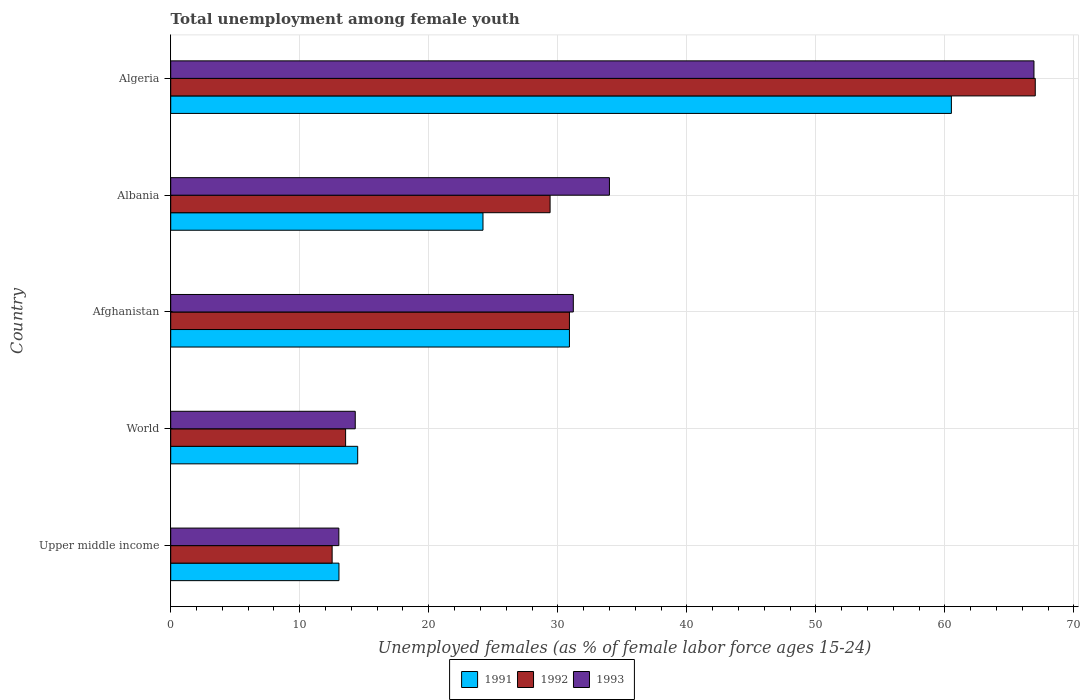How many different coloured bars are there?
Offer a terse response. 3. How many groups of bars are there?
Offer a terse response. 5. What is the label of the 3rd group of bars from the top?
Your response must be concise. Afghanistan. In how many cases, is the number of bars for a given country not equal to the number of legend labels?
Offer a very short reply. 0. What is the percentage of unemployed females in in 1991 in Afghanistan?
Keep it short and to the point. 30.9. Across all countries, what is the maximum percentage of unemployed females in in 1993?
Make the answer very short. 66.9. Across all countries, what is the minimum percentage of unemployed females in in 1993?
Your response must be concise. 13.03. In which country was the percentage of unemployed females in in 1993 maximum?
Give a very brief answer. Algeria. In which country was the percentage of unemployed females in in 1992 minimum?
Offer a very short reply. Upper middle income. What is the total percentage of unemployed females in in 1993 in the graph?
Keep it short and to the point. 159.43. What is the difference between the percentage of unemployed females in in 1992 in Albania and that in World?
Offer a very short reply. 15.85. What is the difference between the percentage of unemployed females in in 1992 in Algeria and the percentage of unemployed females in in 1993 in World?
Provide a succinct answer. 52.7. What is the average percentage of unemployed females in in 1993 per country?
Your answer should be very brief. 31.89. What is the difference between the percentage of unemployed females in in 1992 and percentage of unemployed females in in 1991 in Afghanistan?
Provide a succinct answer. 0. In how many countries, is the percentage of unemployed females in in 1993 greater than 52 %?
Ensure brevity in your answer.  1. What is the ratio of the percentage of unemployed females in in 1992 in Afghanistan to that in Upper middle income?
Provide a succinct answer. 2.47. Is the percentage of unemployed females in in 1992 in Upper middle income less than that in World?
Ensure brevity in your answer.  Yes. Is the difference between the percentage of unemployed females in in 1992 in Algeria and World greater than the difference between the percentage of unemployed females in in 1991 in Algeria and World?
Your answer should be very brief. Yes. What is the difference between the highest and the second highest percentage of unemployed females in in 1991?
Provide a short and direct response. 29.6. What is the difference between the highest and the lowest percentage of unemployed females in in 1992?
Provide a succinct answer. 54.49. What does the 2nd bar from the bottom in World represents?
Give a very brief answer. 1992. Is it the case that in every country, the sum of the percentage of unemployed females in in 1992 and percentage of unemployed females in in 1993 is greater than the percentage of unemployed females in in 1991?
Offer a terse response. Yes. How many countries are there in the graph?
Keep it short and to the point. 5. Are the values on the major ticks of X-axis written in scientific E-notation?
Ensure brevity in your answer.  No. Does the graph contain any zero values?
Your answer should be compact. No. Where does the legend appear in the graph?
Ensure brevity in your answer.  Bottom center. How many legend labels are there?
Ensure brevity in your answer.  3. What is the title of the graph?
Give a very brief answer. Total unemployment among female youth. Does "1983" appear as one of the legend labels in the graph?
Keep it short and to the point. No. What is the label or title of the X-axis?
Provide a short and direct response. Unemployed females (as % of female labor force ages 15-24). What is the label or title of the Y-axis?
Give a very brief answer. Country. What is the Unemployed females (as % of female labor force ages 15-24) in 1991 in Upper middle income?
Ensure brevity in your answer.  13.04. What is the Unemployed females (as % of female labor force ages 15-24) in 1992 in Upper middle income?
Offer a very short reply. 12.51. What is the Unemployed females (as % of female labor force ages 15-24) of 1993 in Upper middle income?
Keep it short and to the point. 13.03. What is the Unemployed females (as % of female labor force ages 15-24) in 1991 in World?
Offer a very short reply. 14.49. What is the Unemployed females (as % of female labor force ages 15-24) in 1992 in World?
Make the answer very short. 13.55. What is the Unemployed females (as % of female labor force ages 15-24) in 1993 in World?
Provide a short and direct response. 14.3. What is the Unemployed females (as % of female labor force ages 15-24) of 1991 in Afghanistan?
Provide a short and direct response. 30.9. What is the Unemployed females (as % of female labor force ages 15-24) of 1992 in Afghanistan?
Offer a very short reply. 30.9. What is the Unemployed females (as % of female labor force ages 15-24) in 1993 in Afghanistan?
Ensure brevity in your answer.  31.2. What is the Unemployed females (as % of female labor force ages 15-24) of 1991 in Albania?
Keep it short and to the point. 24.2. What is the Unemployed females (as % of female labor force ages 15-24) in 1992 in Albania?
Offer a terse response. 29.4. What is the Unemployed females (as % of female labor force ages 15-24) of 1991 in Algeria?
Make the answer very short. 60.5. What is the Unemployed females (as % of female labor force ages 15-24) of 1992 in Algeria?
Provide a short and direct response. 67. What is the Unemployed females (as % of female labor force ages 15-24) of 1993 in Algeria?
Give a very brief answer. 66.9. Across all countries, what is the maximum Unemployed females (as % of female labor force ages 15-24) in 1991?
Offer a terse response. 60.5. Across all countries, what is the maximum Unemployed females (as % of female labor force ages 15-24) of 1992?
Your response must be concise. 67. Across all countries, what is the maximum Unemployed females (as % of female labor force ages 15-24) in 1993?
Provide a short and direct response. 66.9. Across all countries, what is the minimum Unemployed females (as % of female labor force ages 15-24) in 1991?
Your response must be concise. 13.04. Across all countries, what is the minimum Unemployed females (as % of female labor force ages 15-24) of 1992?
Offer a terse response. 12.51. Across all countries, what is the minimum Unemployed females (as % of female labor force ages 15-24) of 1993?
Offer a very short reply. 13.03. What is the total Unemployed females (as % of female labor force ages 15-24) in 1991 in the graph?
Your response must be concise. 143.13. What is the total Unemployed females (as % of female labor force ages 15-24) in 1992 in the graph?
Give a very brief answer. 153.36. What is the total Unemployed females (as % of female labor force ages 15-24) in 1993 in the graph?
Make the answer very short. 159.43. What is the difference between the Unemployed females (as % of female labor force ages 15-24) in 1991 in Upper middle income and that in World?
Offer a terse response. -1.45. What is the difference between the Unemployed females (as % of female labor force ages 15-24) of 1992 in Upper middle income and that in World?
Make the answer very short. -1.04. What is the difference between the Unemployed females (as % of female labor force ages 15-24) of 1993 in Upper middle income and that in World?
Your answer should be compact. -1.27. What is the difference between the Unemployed females (as % of female labor force ages 15-24) in 1991 in Upper middle income and that in Afghanistan?
Give a very brief answer. -17.86. What is the difference between the Unemployed females (as % of female labor force ages 15-24) in 1992 in Upper middle income and that in Afghanistan?
Your answer should be compact. -18.39. What is the difference between the Unemployed females (as % of female labor force ages 15-24) of 1993 in Upper middle income and that in Afghanistan?
Your response must be concise. -18.17. What is the difference between the Unemployed females (as % of female labor force ages 15-24) in 1991 in Upper middle income and that in Albania?
Provide a succinct answer. -11.16. What is the difference between the Unemployed females (as % of female labor force ages 15-24) in 1992 in Upper middle income and that in Albania?
Offer a very short reply. -16.89. What is the difference between the Unemployed females (as % of female labor force ages 15-24) of 1993 in Upper middle income and that in Albania?
Offer a very short reply. -20.97. What is the difference between the Unemployed females (as % of female labor force ages 15-24) in 1991 in Upper middle income and that in Algeria?
Keep it short and to the point. -47.46. What is the difference between the Unemployed females (as % of female labor force ages 15-24) in 1992 in Upper middle income and that in Algeria?
Your answer should be very brief. -54.49. What is the difference between the Unemployed females (as % of female labor force ages 15-24) in 1993 in Upper middle income and that in Algeria?
Make the answer very short. -53.87. What is the difference between the Unemployed females (as % of female labor force ages 15-24) of 1991 in World and that in Afghanistan?
Provide a short and direct response. -16.41. What is the difference between the Unemployed females (as % of female labor force ages 15-24) of 1992 in World and that in Afghanistan?
Offer a terse response. -17.35. What is the difference between the Unemployed females (as % of female labor force ages 15-24) of 1993 in World and that in Afghanistan?
Offer a very short reply. -16.9. What is the difference between the Unemployed females (as % of female labor force ages 15-24) of 1991 in World and that in Albania?
Offer a very short reply. -9.71. What is the difference between the Unemployed females (as % of female labor force ages 15-24) in 1992 in World and that in Albania?
Provide a succinct answer. -15.85. What is the difference between the Unemployed females (as % of female labor force ages 15-24) in 1993 in World and that in Albania?
Your answer should be compact. -19.7. What is the difference between the Unemployed females (as % of female labor force ages 15-24) of 1991 in World and that in Algeria?
Give a very brief answer. -46.01. What is the difference between the Unemployed females (as % of female labor force ages 15-24) of 1992 in World and that in Algeria?
Provide a short and direct response. -53.45. What is the difference between the Unemployed females (as % of female labor force ages 15-24) in 1993 in World and that in Algeria?
Your answer should be compact. -52.6. What is the difference between the Unemployed females (as % of female labor force ages 15-24) in 1991 in Afghanistan and that in Albania?
Make the answer very short. 6.7. What is the difference between the Unemployed females (as % of female labor force ages 15-24) of 1992 in Afghanistan and that in Albania?
Offer a terse response. 1.5. What is the difference between the Unemployed females (as % of female labor force ages 15-24) in 1991 in Afghanistan and that in Algeria?
Make the answer very short. -29.6. What is the difference between the Unemployed females (as % of female labor force ages 15-24) in 1992 in Afghanistan and that in Algeria?
Provide a short and direct response. -36.1. What is the difference between the Unemployed females (as % of female labor force ages 15-24) in 1993 in Afghanistan and that in Algeria?
Your answer should be very brief. -35.7. What is the difference between the Unemployed females (as % of female labor force ages 15-24) of 1991 in Albania and that in Algeria?
Offer a terse response. -36.3. What is the difference between the Unemployed females (as % of female labor force ages 15-24) in 1992 in Albania and that in Algeria?
Keep it short and to the point. -37.6. What is the difference between the Unemployed females (as % of female labor force ages 15-24) of 1993 in Albania and that in Algeria?
Keep it short and to the point. -32.9. What is the difference between the Unemployed females (as % of female labor force ages 15-24) in 1991 in Upper middle income and the Unemployed females (as % of female labor force ages 15-24) in 1992 in World?
Give a very brief answer. -0.52. What is the difference between the Unemployed females (as % of female labor force ages 15-24) of 1991 in Upper middle income and the Unemployed females (as % of female labor force ages 15-24) of 1993 in World?
Offer a very short reply. -1.26. What is the difference between the Unemployed females (as % of female labor force ages 15-24) of 1992 in Upper middle income and the Unemployed females (as % of female labor force ages 15-24) of 1993 in World?
Provide a short and direct response. -1.79. What is the difference between the Unemployed females (as % of female labor force ages 15-24) in 1991 in Upper middle income and the Unemployed females (as % of female labor force ages 15-24) in 1992 in Afghanistan?
Give a very brief answer. -17.86. What is the difference between the Unemployed females (as % of female labor force ages 15-24) of 1991 in Upper middle income and the Unemployed females (as % of female labor force ages 15-24) of 1993 in Afghanistan?
Offer a very short reply. -18.16. What is the difference between the Unemployed females (as % of female labor force ages 15-24) in 1992 in Upper middle income and the Unemployed females (as % of female labor force ages 15-24) in 1993 in Afghanistan?
Offer a very short reply. -18.69. What is the difference between the Unemployed females (as % of female labor force ages 15-24) of 1991 in Upper middle income and the Unemployed females (as % of female labor force ages 15-24) of 1992 in Albania?
Your answer should be compact. -16.36. What is the difference between the Unemployed females (as % of female labor force ages 15-24) in 1991 in Upper middle income and the Unemployed females (as % of female labor force ages 15-24) in 1993 in Albania?
Offer a very short reply. -20.96. What is the difference between the Unemployed females (as % of female labor force ages 15-24) in 1992 in Upper middle income and the Unemployed females (as % of female labor force ages 15-24) in 1993 in Albania?
Provide a short and direct response. -21.49. What is the difference between the Unemployed females (as % of female labor force ages 15-24) of 1991 in Upper middle income and the Unemployed females (as % of female labor force ages 15-24) of 1992 in Algeria?
Provide a succinct answer. -53.96. What is the difference between the Unemployed females (as % of female labor force ages 15-24) in 1991 in Upper middle income and the Unemployed females (as % of female labor force ages 15-24) in 1993 in Algeria?
Offer a very short reply. -53.86. What is the difference between the Unemployed females (as % of female labor force ages 15-24) of 1992 in Upper middle income and the Unemployed females (as % of female labor force ages 15-24) of 1993 in Algeria?
Keep it short and to the point. -54.39. What is the difference between the Unemployed females (as % of female labor force ages 15-24) of 1991 in World and the Unemployed females (as % of female labor force ages 15-24) of 1992 in Afghanistan?
Ensure brevity in your answer.  -16.41. What is the difference between the Unemployed females (as % of female labor force ages 15-24) in 1991 in World and the Unemployed females (as % of female labor force ages 15-24) in 1993 in Afghanistan?
Your response must be concise. -16.71. What is the difference between the Unemployed females (as % of female labor force ages 15-24) in 1992 in World and the Unemployed females (as % of female labor force ages 15-24) in 1993 in Afghanistan?
Provide a short and direct response. -17.65. What is the difference between the Unemployed females (as % of female labor force ages 15-24) in 1991 in World and the Unemployed females (as % of female labor force ages 15-24) in 1992 in Albania?
Provide a succinct answer. -14.91. What is the difference between the Unemployed females (as % of female labor force ages 15-24) in 1991 in World and the Unemployed females (as % of female labor force ages 15-24) in 1993 in Albania?
Your response must be concise. -19.51. What is the difference between the Unemployed females (as % of female labor force ages 15-24) of 1992 in World and the Unemployed females (as % of female labor force ages 15-24) of 1993 in Albania?
Your answer should be very brief. -20.45. What is the difference between the Unemployed females (as % of female labor force ages 15-24) in 1991 in World and the Unemployed females (as % of female labor force ages 15-24) in 1992 in Algeria?
Your answer should be very brief. -52.51. What is the difference between the Unemployed females (as % of female labor force ages 15-24) in 1991 in World and the Unemployed females (as % of female labor force ages 15-24) in 1993 in Algeria?
Provide a succinct answer. -52.41. What is the difference between the Unemployed females (as % of female labor force ages 15-24) in 1992 in World and the Unemployed females (as % of female labor force ages 15-24) in 1993 in Algeria?
Make the answer very short. -53.35. What is the difference between the Unemployed females (as % of female labor force ages 15-24) in 1991 in Afghanistan and the Unemployed females (as % of female labor force ages 15-24) in 1992 in Albania?
Offer a very short reply. 1.5. What is the difference between the Unemployed females (as % of female labor force ages 15-24) of 1991 in Afghanistan and the Unemployed females (as % of female labor force ages 15-24) of 1992 in Algeria?
Provide a short and direct response. -36.1. What is the difference between the Unemployed females (as % of female labor force ages 15-24) in 1991 in Afghanistan and the Unemployed females (as % of female labor force ages 15-24) in 1993 in Algeria?
Your answer should be very brief. -36. What is the difference between the Unemployed females (as % of female labor force ages 15-24) of 1992 in Afghanistan and the Unemployed females (as % of female labor force ages 15-24) of 1993 in Algeria?
Your response must be concise. -36. What is the difference between the Unemployed females (as % of female labor force ages 15-24) in 1991 in Albania and the Unemployed females (as % of female labor force ages 15-24) in 1992 in Algeria?
Provide a succinct answer. -42.8. What is the difference between the Unemployed females (as % of female labor force ages 15-24) in 1991 in Albania and the Unemployed females (as % of female labor force ages 15-24) in 1993 in Algeria?
Your response must be concise. -42.7. What is the difference between the Unemployed females (as % of female labor force ages 15-24) in 1992 in Albania and the Unemployed females (as % of female labor force ages 15-24) in 1993 in Algeria?
Your response must be concise. -37.5. What is the average Unemployed females (as % of female labor force ages 15-24) of 1991 per country?
Ensure brevity in your answer.  28.63. What is the average Unemployed females (as % of female labor force ages 15-24) in 1992 per country?
Offer a terse response. 30.67. What is the average Unemployed females (as % of female labor force ages 15-24) of 1993 per country?
Give a very brief answer. 31.89. What is the difference between the Unemployed females (as % of female labor force ages 15-24) of 1991 and Unemployed females (as % of female labor force ages 15-24) of 1992 in Upper middle income?
Provide a short and direct response. 0.53. What is the difference between the Unemployed females (as % of female labor force ages 15-24) of 1991 and Unemployed females (as % of female labor force ages 15-24) of 1993 in Upper middle income?
Keep it short and to the point. 0.01. What is the difference between the Unemployed females (as % of female labor force ages 15-24) in 1992 and Unemployed females (as % of female labor force ages 15-24) in 1993 in Upper middle income?
Offer a terse response. -0.52. What is the difference between the Unemployed females (as % of female labor force ages 15-24) in 1991 and Unemployed females (as % of female labor force ages 15-24) in 1992 in World?
Keep it short and to the point. 0.94. What is the difference between the Unemployed females (as % of female labor force ages 15-24) in 1991 and Unemployed females (as % of female labor force ages 15-24) in 1993 in World?
Make the answer very short. 0.19. What is the difference between the Unemployed females (as % of female labor force ages 15-24) in 1992 and Unemployed females (as % of female labor force ages 15-24) in 1993 in World?
Your answer should be very brief. -0.75. What is the difference between the Unemployed females (as % of female labor force ages 15-24) in 1991 and Unemployed females (as % of female labor force ages 15-24) in 1992 in Afghanistan?
Your response must be concise. 0. What is the difference between the Unemployed females (as % of female labor force ages 15-24) of 1992 and Unemployed females (as % of female labor force ages 15-24) of 1993 in Albania?
Provide a succinct answer. -4.6. What is the difference between the Unemployed females (as % of female labor force ages 15-24) of 1991 and Unemployed females (as % of female labor force ages 15-24) of 1992 in Algeria?
Give a very brief answer. -6.5. What is the ratio of the Unemployed females (as % of female labor force ages 15-24) in 1991 in Upper middle income to that in World?
Your response must be concise. 0.9. What is the ratio of the Unemployed females (as % of female labor force ages 15-24) of 1992 in Upper middle income to that in World?
Your answer should be compact. 0.92. What is the ratio of the Unemployed females (as % of female labor force ages 15-24) in 1993 in Upper middle income to that in World?
Offer a very short reply. 0.91. What is the ratio of the Unemployed females (as % of female labor force ages 15-24) in 1991 in Upper middle income to that in Afghanistan?
Your answer should be very brief. 0.42. What is the ratio of the Unemployed females (as % of female labor force ages 15-24) in 1992 in Upper middle income to that in Afghanistan?
Ensure brevity in your answer.  0.4. What is the ratio of the Unemployed females (as % of female labor force ages 15-24) in 1993 in Upper middle income to that in Afghanistan?
Provide a short and direct response. 0.42. What is the ratio of the Unemployed females (as % of female labor force ages 15-24) of 1991 in Upper middle income to that in Albania?
Your response must be concise. 0.54. What is the ratio of the Unemployed females (as % of female labor force ages 15-24) in 1992 in Upper middle income to that in Albania?
Keep it short and to the point. 0.43. What is the ratio of the Unemployed females (as % of female labor force ages 15-24) of 1993 in Upper middle income to that in Albania?
Make the answer very short. 0.38. What is the ratio of the Unemployed females (as % of female labor force ages 15-24) in 1991 in Upper middle income to that in Algeria?
Your response must be concise. 0.22. What is the ratio of the Unemployed females (as % of female labor force ages 15-24) in 1992 in Upper middle income to that in Algeria?
Your response must be concise. 0.19. What is the ratio of the Unemployed females (as % of female labor force ages 15-24) in 1993 in Upper middle income to that in Algeria?
Give a very brief answer. 0.19. What is the ratio of the Unemployed females (as % of female labor force ages 15-24) in 1991 in World to that in Afghanistan?
Offer a very short reply. 0.47. What is the ratio of the Unemployed females (as % of female labor force ages 15-24) in 1992 in World to that in Afghanistan?
Make the answer very short. 0.44. What is the ratio of the Unemployed females (as % of female labor force ages 15-24) in 1993 in World to that in Afghanistan?
Offer a very short reply. 0.46. What is the ratio of the Unemployed females (as % of female labor force ages 15-24) of 1991 in World to that in Albania?
Your answer should be compact. 0.6. What is the ratio of the Unemployed females (as % of female labor force ages 15-24) of 1992 in World to that in Albania?
Provide a succinct answer. 0.46. What is the ratio of the Unemployed females (as % of female labor force ages 15-24) in 1993 in World to that in Albania?
Provide a short and direct response. 0.42. What is the ratio of the Unemployed females (as % of female labor force ages 15-24) of 1991 in World to that in Algeria?
Your response must be concise. 0.24. What is the ratio of the Unemployed females (as % of female labor force ages 15-24) in 1992 in World to that in Algeria?
Offer a terse response. 0.2. What is the ratio of the Unemployed females (as % of female labor force ages 15-24) of 1993 in World to that in Algeria?
Provide a short and direct response. 0.21. What is the ratio of the Unemployed females (as % of female labor force ages 15-24) in 1991 in Afghanistan to that in Albania?
Provide a short and direct response. 1.28. What is the ratio of the Unemployed females (as % of female labor force ages 15-24) in 1992 in Afghanistan to that in Albania?
Provide a short and direct response. 1.05. What is the ratio of the Unemployed females (as % of female labor force ages 15-24) of 1993 in Afghanistan to that in Albania?
Give a very brief answer. 0.92. What is the ratio of the Unemployed females (as % of female labor force ages 15-24) of 1991 in Afghanistan to that in Algeria?
Provide a succinct answer. 0.51. What is the ratio of the Unemployed females (as % of female labor force ages 15-24) in 1992 in Afghanistan to that in Algeria?
Your answer should be compact. 0.46. What is the ratio of the Unemployed females (as % of female labor force ages 15-24) of 1993 in Afghanistan to that in Algeria?
Make the answer very short. 0.47. What is the ratio of the Unemployed females (as % of female labor force ages 15-24) of 1991 in Albania to that in Algeria?
Provide a succinct answer. 0.4. What is the ratio of the Unemployed females (as % of female labor force ages 15-24) of 1992 in Albania to that in Algeria?
Provide a short and direct response. 0.44. What is the ratio of the Unemployed females (as % of female labor force ages 15-24) of 1993 in Albania to that in Algeria?
Your response must be concise. 0.51. What is the difference between the highest and the second highest Unemployed females (as % of female labor force ages 15-24) of 1991?
Offer a very short reply. 29.6. What is the difference between the highest and the second highest Unemployed females (as % of female labor force ages 15-24) of 1992?
Make the answer very short. 36.1. What is the difference between the highest and the second highest Unemployed females (as % of female labor force ages 15-24) of 1993?
Your response must be concise. 32.9. What is the difference between the highest and the lowest Unemployed females (as % of female labor force ages 15-24) in 1991?
Give a very brief answer. 47.46. What is the difference between the highest and the lowest Unemployed females (as % of female labor force ages 15-24) in 1992?
Your answer should be compact. 54.49. What is the difference between the highest and the lowest Unemployed females (as % of female labor force ages 15-24) in 1993?
Keep it short and to the point. 53.87. 